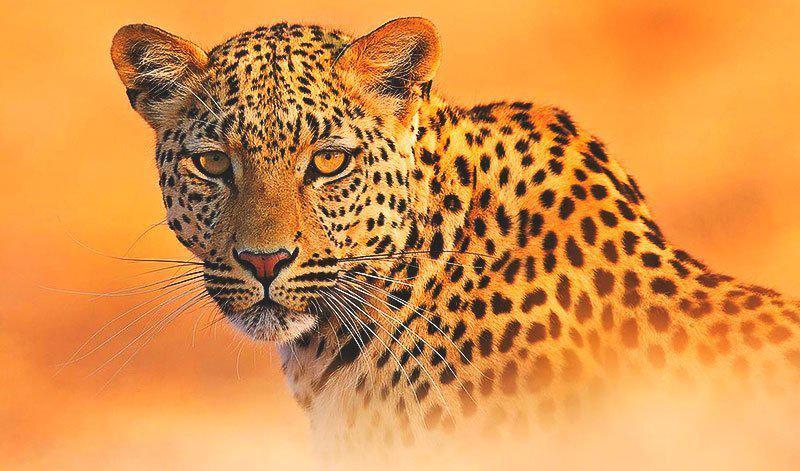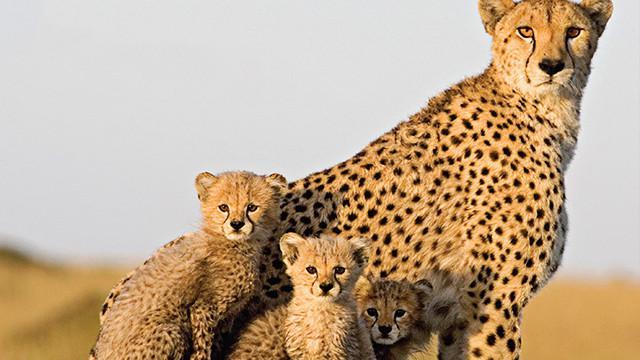The first image is the image on the left, the second image is the image on the right. For the images displayed, is the sentence "A single cheetah is leaping in the air in the left image." factually correct? Answer yes or no. No. The first image is the image on the left, the second image is the image on the right. Given the left and right images, does the statement "There is a mother cheetah sitting and watching as her 3 cubs are close to her" hold true? Answer yes or no. Yes. 